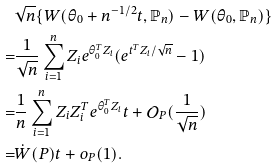<formula> <loc_0><loc_0><loc_500><loc_500>& \sqrt { n } \{ W ( \theta _ { 0 } + n ^ { - 1 / 2 } t , \mathbb { P } _ { n } ) - W ( \theta _ { 0 } , \mathbb { P } _ { n } ) \} \\ = & \frac { 1 } { \sqrt { n } } \sum _ { i = 1 } ^ { n } Z _ { i } e ^ { \theta _ { 0 } ^ { T } Z _ { i } } ( e ^ { t ^ { T } Z _ { i } / \sqrt { n } } - 1 ) \\ = & \frac { 1 } { n } \sum _ { i = 1 } ^ { n } Z _ { i } Z _ { i } ^ { T } e ^ { \theta _ { 0 } ^ { T } Z _ { i } } t + \mathcal { O } _ { P } ( \frac { 1 } { \sqrt { n } } ) \\ = & \dot { W } ( P ) t + o _ { P } ( 1 ) .</formula> 